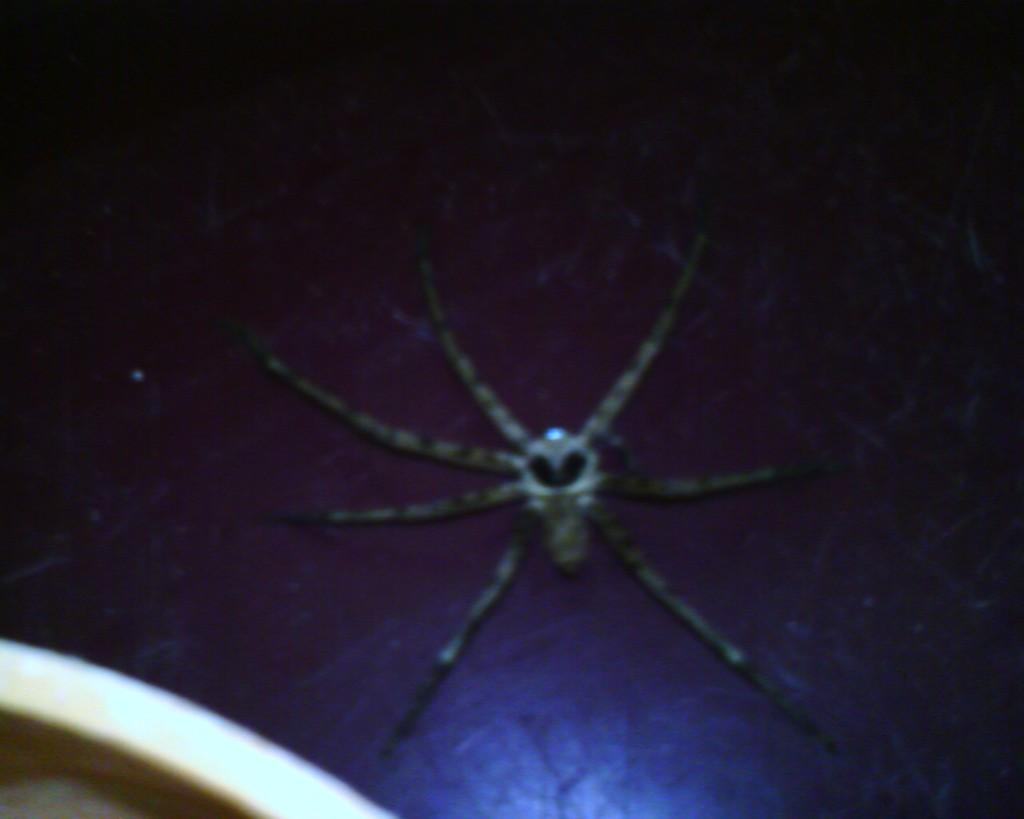What is the overall color scheme of the background in the image? The background of the picture is dark. What type of creature can be seen on the dark surface? There is a spider visible on the dark surface. Can you describe the object located in the bottom left corner of the picture? Unfortunately, the provided facts do not give any information about the object in the bottom left corner of the picture. What type of button is being used for breakfast in the image? There is no button or reference to breakfast in the image; it features a spider on a dark surface. 